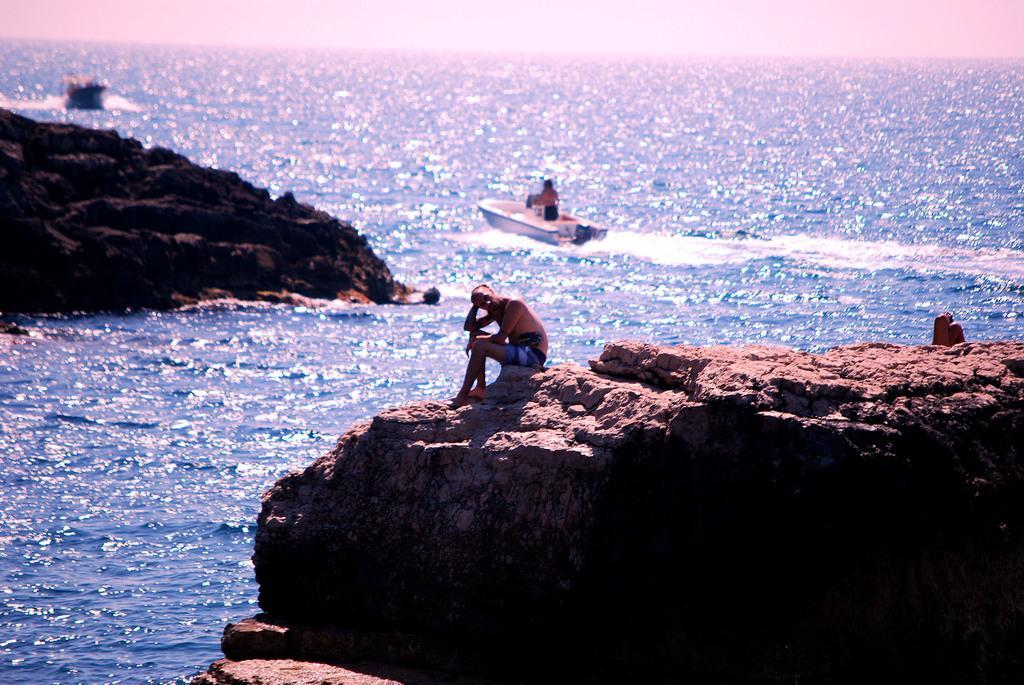How would you summarize this image in a sentence or two? This image consists of three persons three persons sitting near the ocean. In the front, we can see a man sitting on the rock. In the middle, there is a person travelling in the boat. At the top, we can see the sky. 